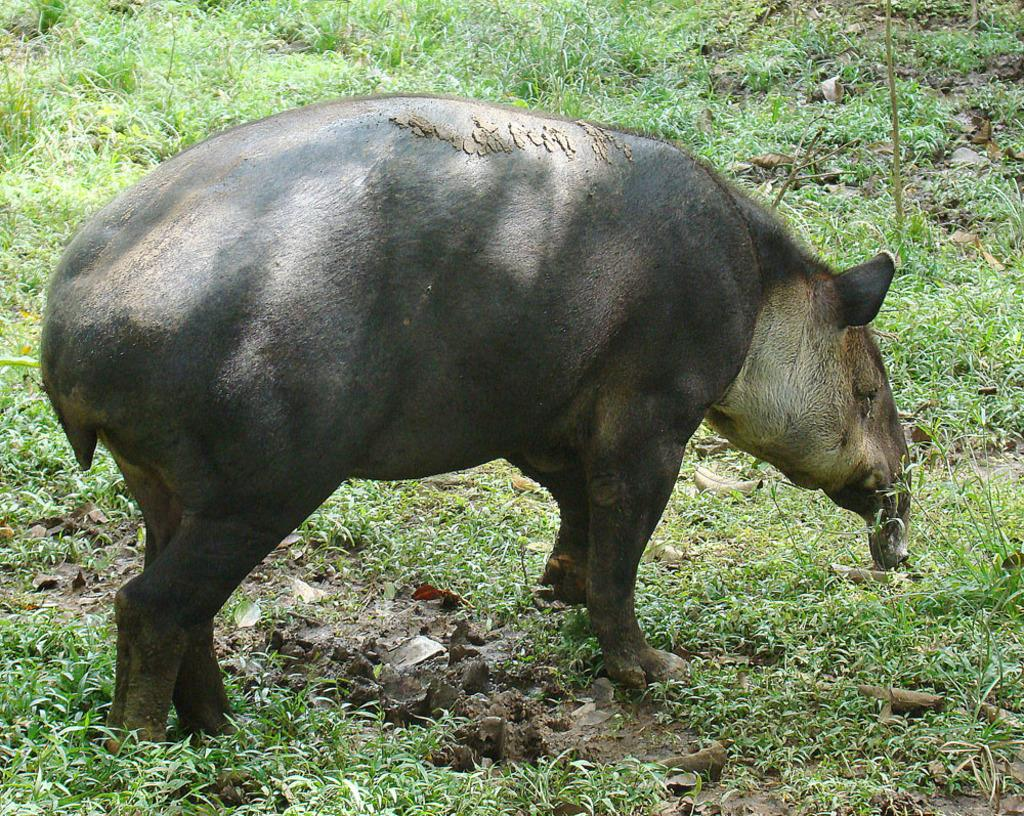What type of animal can be seen in the foreground of the image? There is an animal in the foreground of the image, but the specific type cannot be determined from the provided facts. What is the terrain like in the image? Grass is present in the image, indicating that the terrain is grassy. How many matches are visible in the image? There is no mention of matches in the image, so it cannot be determined if any are present. 